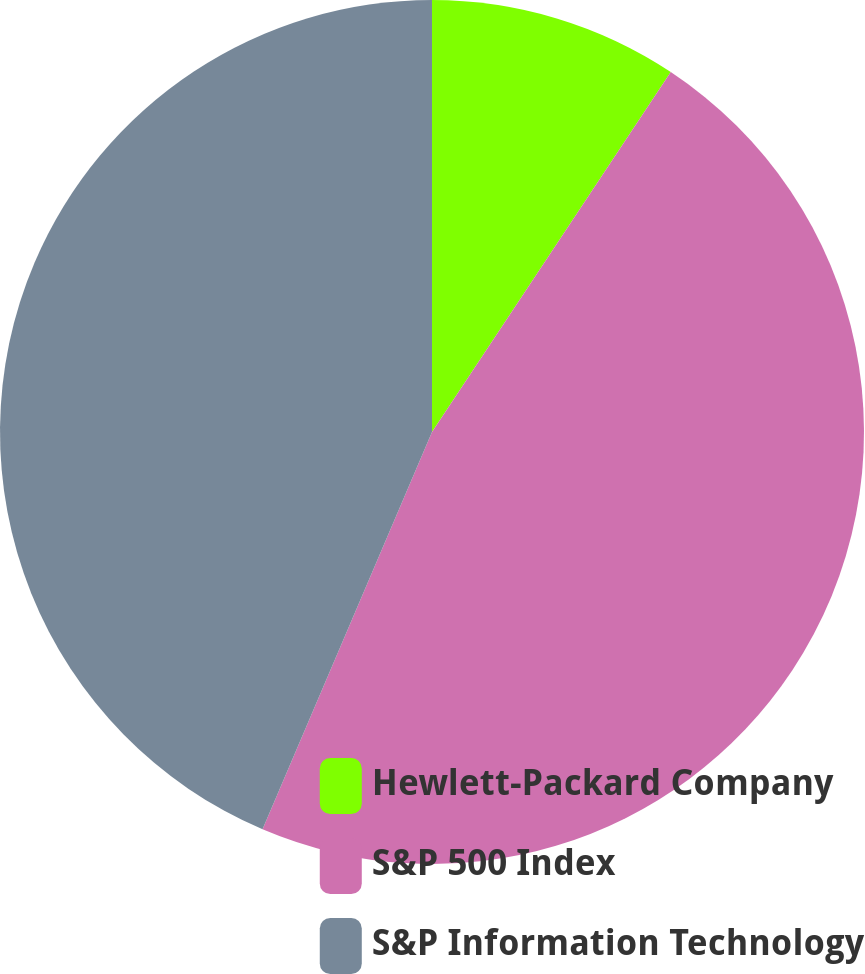Convert chart. <chart><loc_0><loc_0><loc_500><loc_500><pie_chart><fcel>Hewlett-Packard Company<fcel>S&P 500 Index<fcel>S&P Information Technology<nl><fcel>9.32%<fcel>47.09%<fcel>43.58%<nl></chart> 